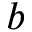<formula> <loc_0><loc_0><loc_500><loc_500>b</formula> 